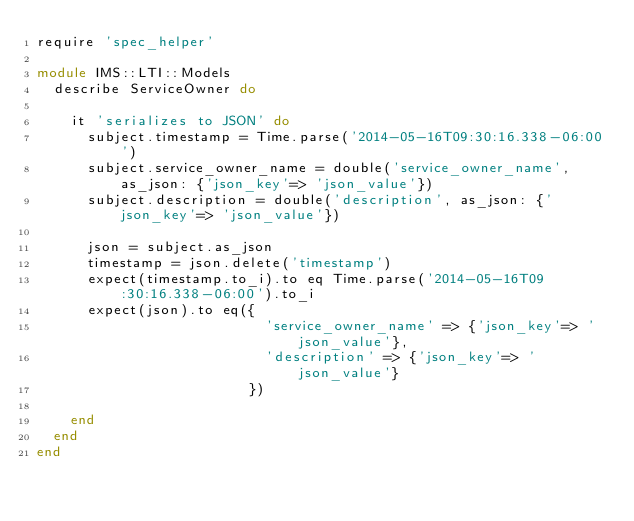<code> <loc_0><loc_0><loc_500><loc_500><_Ruby_>require 'spec_helper'

module IMS::LTI::Models
  describe ServiceOwner do

    it 'serializes to JSON' do
      subject.timestamp = Time.parse('2014-05-16T09:30:16.338-06:00')
      subject.service_owner_name = double('service_owner_name', as_json: {'json_key'=> 'json_value'})
      subject.description = double('description', as_json: {'json_key'=> 'json_value'})

      json = subject.as_json
      timestamp = json.delete('timestamp')
      expect(timestamp.to_i).to eq Time.parse('2014-05-16T09:30:16.338-06:00').to_i
      expect(json).to eq({
                           'service_owner_name' => {'json_key'=> 'json_value'},
                           'description' => {'json_key'=> 'json_value'}
                         })

    end
  end
end</code> 